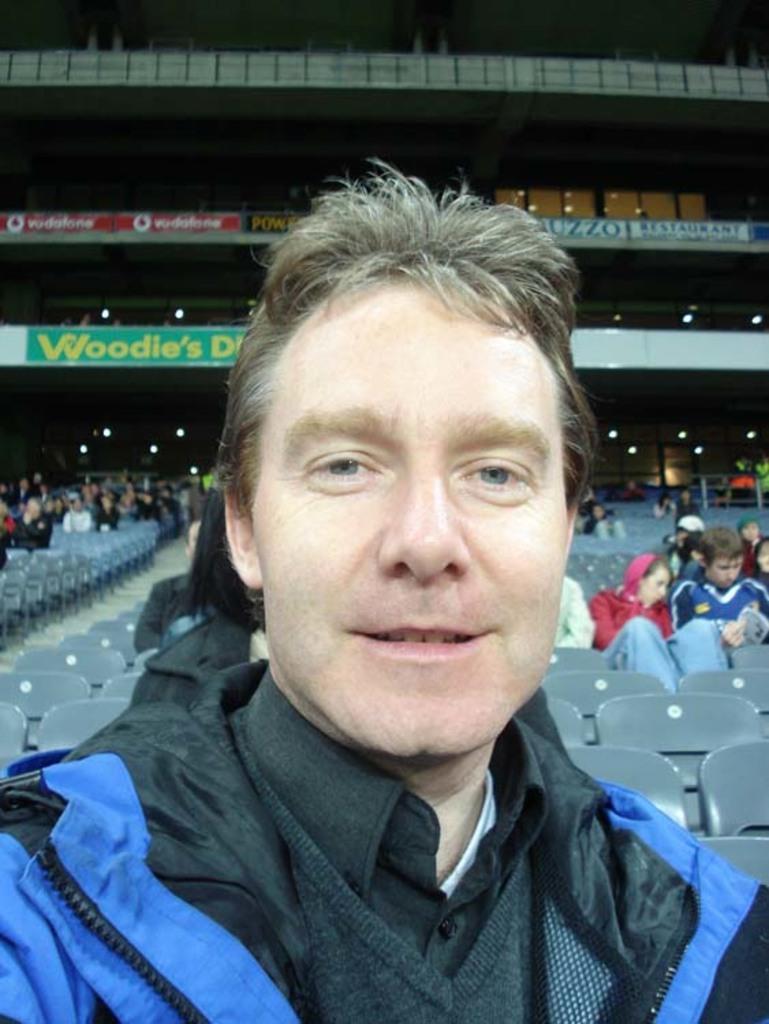Can you describe this image briefly? In the center of the image there is a person wearing a jacket. In the background of the image there are people sitting in chairs. 